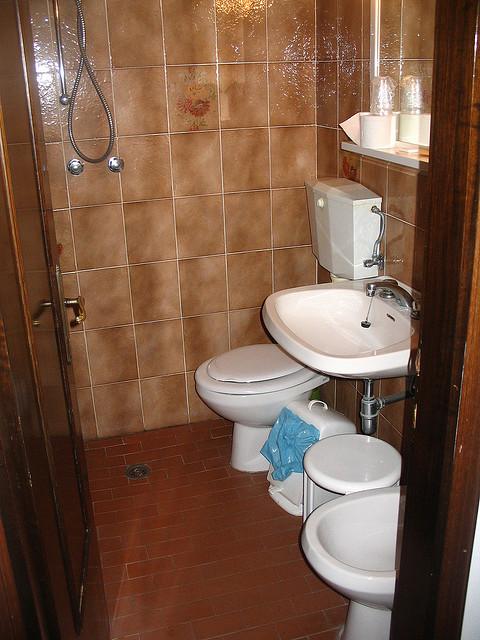Is the toilet lid up or down?
Write a very short answer. Down. What is the flooring material?
Keep it brief. Tile. What color are the tiles?
Keep it brief. Brown. 